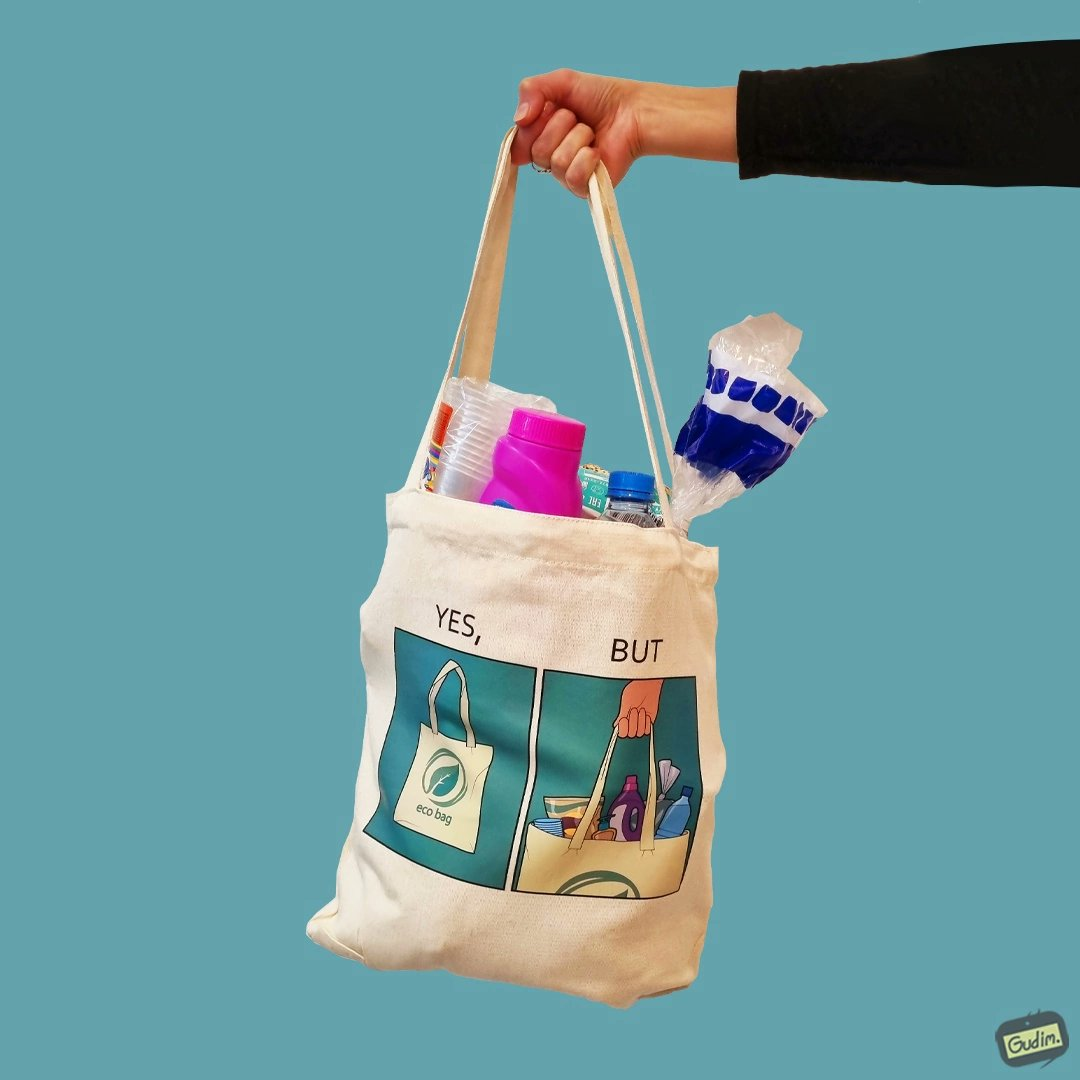Would you classify this image as satirical? Yes, this image is satirical. 